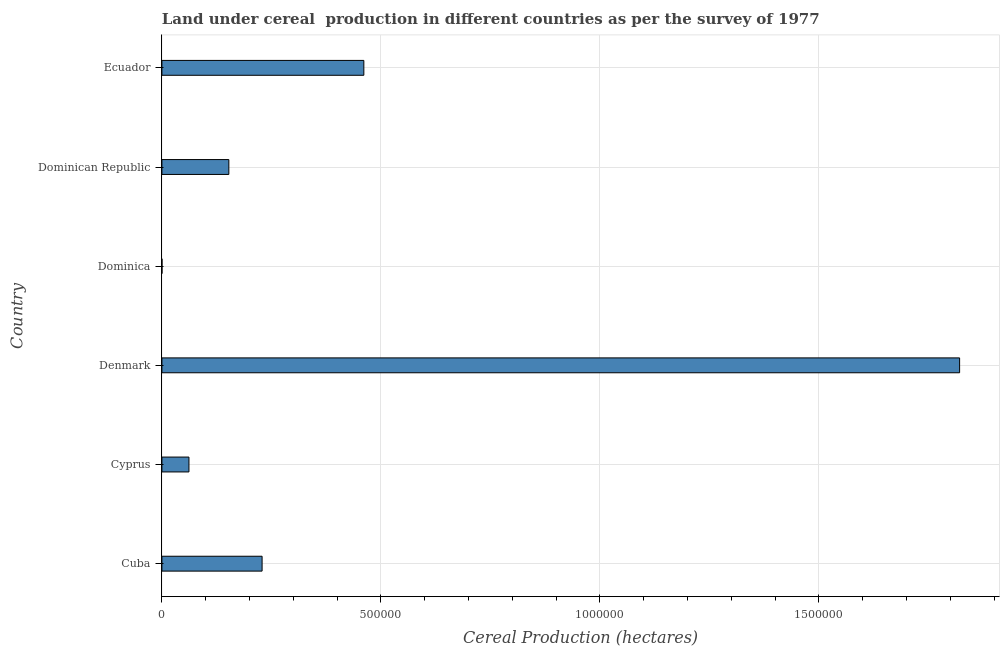Does the graph contain grids?
Offer a terse response. Yes. What is the title of the graph?
Your response must be concise. Land under cereal  production in different countries as per the survey of 1977. What is the label or title of the X-axis?
Provide a short and direct response. Cereal Production (hectares). What is the land under cereal production in Denmark?
Your answer should be compact. 1.82e+06. Across all countries, what is the maximum land under cereal production?
Make the answer very short. 1.82e+06. Across all countries, what is the minimum land under cereal production?
Provide a short and direct response. 150. In which country was the land under cereal production minimum?
Your response must be concise. Dominica. What is the sum of the land under cereal production?
Your answer should be compact. 2.73e+06. What is the difference between the land under cereal production in Cuba and Dominica?
Your answer should be compact. 2.29e+05. What is the average land under cereal production per country?
Your response must be concise. 4.54e+05. What is the median land under cereal production?
Provide a succinct answer. 1.91e+05. In how many countries, is the land under cereal production greater than 200000 hectares?
Offer a terse response. 3. What is the ratio of the land under cereal production in Cuba to that in Ecuador?
Ensure brevity in your answer.  0.5. Is the difference between the land under cereal production in Denmark and Dominica greater than the difference between any two countries?
Give a very brief answer. Yes. What is the difference between the highest and the second highest land under cereal production?
Offer a terse response. 1.36e+06. Is the sum of the land under cereal production in Cuba and Dominican Republic greater than the maximum land under cereal production across all countries?
Your response must be concise. No. What is the difference between the highest and the lowest land under cereal production?
Offer a terse response. 1.82e+06. In how many countries, is the land under cereal production greater than the average land under cereal production taken over all countries?
Ensure brevity in your answer.  2. What is the Cereal Production (hectares) in Cuba?
Your response must be concise. 2.29e+05. What is the Cereal Production (hectares) of Cyprus?
Offer a terse response. 6.18e+04. What is the Cereal Production (hectares) of Denmark?
Offer a very short reply. 1.82e+06. What is the Cereal Production (hectares) in Dominica?
Your response must be concise. 150. What is the Cereal Production (hectares) in Dominican Republic?
Your answer should be compact. 1.53e+05. What is the Cereal Production (hectares) in Ecuador?
Your response must be concise. 4.61e+05. What is the difference between the Cereal Production (hectares) in Cuba and Cyprus?
Offer a very short reply. 1.67e+05. What is the difference between the Cereal Production (hectares) in Cuba and Denmark?
Keep it short and to the point. -1.59e+06. What is the difference between the Cereal Production (hectares) in Cuba and Dominica?
Provide a short and direct response. 2.29e+05. What is the difference between the Cereal Production (hectares) in Cuba and Dominican Republic?
Keep it short and to the point. 7.59e+04. What is the difference between the Cereal Production (hectares) in Cuba and Ecuador?
Provide a short and direct response. -2.32e+05. What is the difference between the Cereal Production (hectares) in Cyprus and Denmark?
Offer a terse response. -1.76e+06. What is the difference between the Cereal Production (hectares) in Cyprus and Dominica?
Give a very brief answer. 6.16e+04. What is the difference between the Cereal Production (hectares) in Cyprus and Dominican Republic?
Provide a succinct answer. -9.11e+04. What is the difference between the Cereal Production (hectares) in Cyprus and Ecuador?
Offer a terse response. -3.99e+05. What is the difference between the Cereal Production (hectares) in Denmark and Dominica?
Your answer should be compact. 1.82e+06. What is the difference between the Cereal Production (hectares) in Denmark and Dominican Republic?
Keep it short and to the point. 1.67e+06. What is the difference between the Cereal Production (hectares) in Denmark and Ecuador?
Offer a very short reply. 1.36e+06. What is the difference between the Cereal Production (hectares) in Dominica and Dominican Republic?
Make the answer very short. -1.53e+05. What is the difference between the Cereal Production (hectares) in Dominica and Ecuador?
Offer a terse response. -4.61e+05. What is the difference between the Cereal Production (hectares) in Dominican Republic and Ecuador?
Provide a succinct answer. -3.08e+05. What is the ratio of the Cereal Production (hectares) in Cuba to that in Cyprus?
Your answer should be compact. 3.7. What is the ratio of the Cereal Production (hectares) in Cuba to that in Denmark?
Your answer should be very brief. 0.13. What is the ratio of the Cereal Production (hectares) in Cuba to that in Dominica?
Keep it short and to the point. 1525.07. What is the ratio of the Cereal Production (hectares) in Cuba to that in Dominican Republic?
Make the answer very short. 1.5. What is the ratio of the Cereal Production (hectares) in Cuba to that in Ecuador?
Offer a terse response. 0.5. What is the ratio of the Cereal Production (hectares) in Cyprus to that in Denmark?
Offer a very short reply. 0.03. What is the ratio of the Cereal Production (hectares) in Cyprus to that in Dominica?
Keep it short and to the point. 411.82. What is the ratio of the Cereal Production (hectares) in Cyprus to that in Dominican Republic?
Your answer should be compact. 0.4. What is the ratio of the Cereal Production (hectares) in Cyprus to that in Ecuador?
Offer a terse response. 0.13. What is the ratio of the Cereal Production (hectares) in Denmark to that in Dominica?
Provide a succinct answer. 1.21e+04. What is the ratio of the Cereal Production (hectares) in Denmark to that in Dominican Republic?
Ensure brevity in your answer.  11.91. What is the ratio of the Cereal Production (hectares) in Denmark to that in Ecuador?
Offer a very short reply. 3.95. What is the ratio of the Cereal Production (hectares) in Dominica to that in Dominican Republic?
Offer a very short reply. 0. What is the ratio of the Cereal Production (hectares) in Dominican Republic to that in Ecuador?
Ensure brevity in your answer.  0.33. 